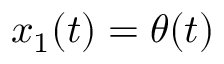<formula> <loc_0><loc_0><loc_500><loc_500>x _ { 1 } ( t ) = \theta ( t )</formula> 